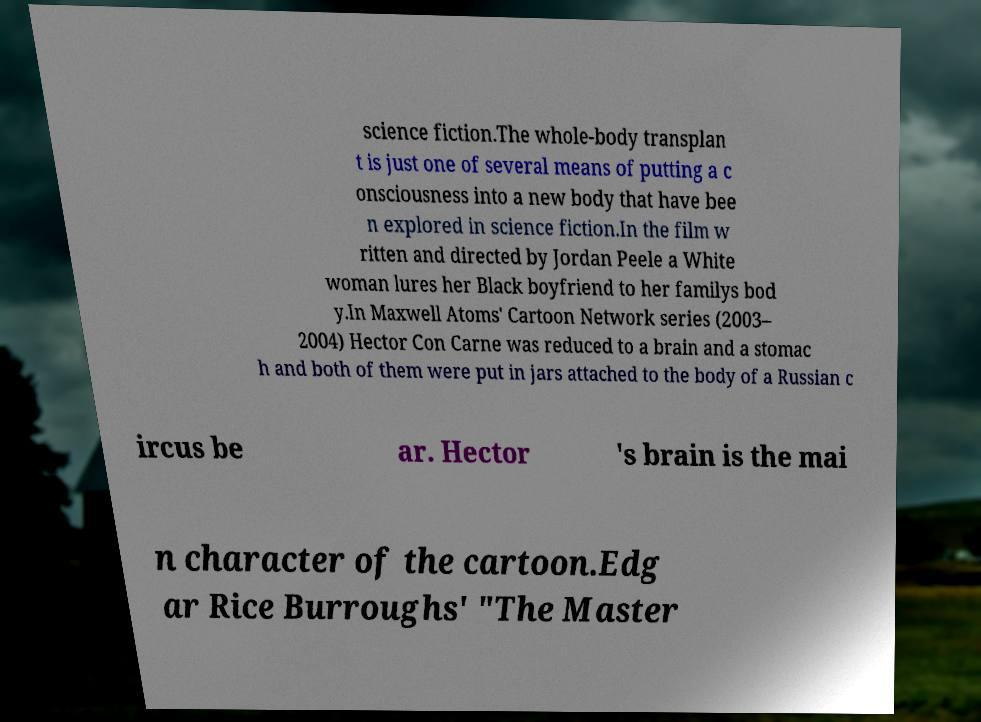Could you extract and type out the text from this image? science fiction.The whole-body transplan t is just one of several means of putting a c onsciousness into a new body that have bee n explored in science fiction.In the film w ritten and directed by Jordan Peele a White woman lures her Black boyfriend to her familys bod y.In Maxwell Atoms' Cartoon Network series (2003– 2004) Hector Con Carne was reduced to a brain and a stomac h and both of them were put in jars attached to the body of a Russian c ircus be ar. Hector 's brain is the mai n character of the cartoon.Edg ar Rice Burroughs' "The Master 